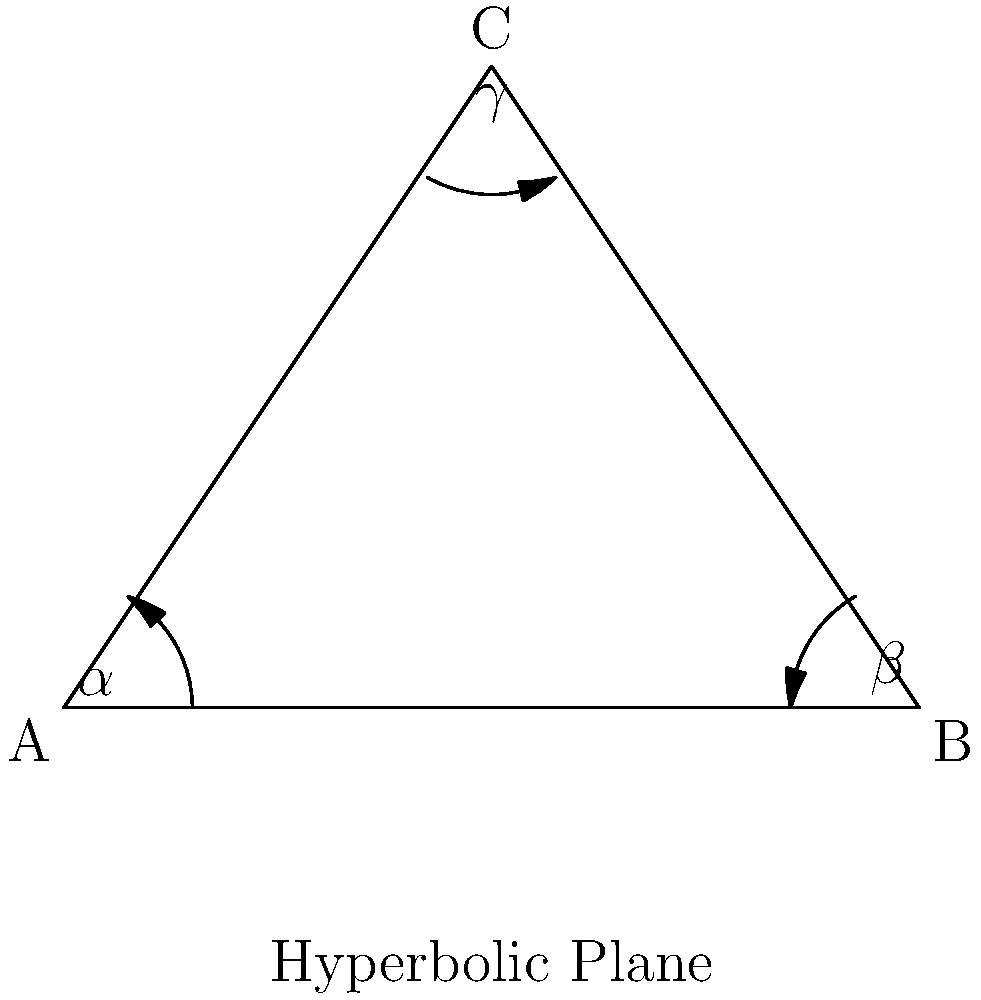Em um plano hiperbólico, um triângulo tem ângulos internos $\alpha$, $\beta$, e $\gamma$. Sabendo que a soma dos ângulos internos de um triângulo em um plano hiperbólico é sempre menor que 180°, e que neste triângulo específico a soma é igual a 150°, qual é o valor da deficiência angular (a diferença entre 180° e a soma dos ângulos internos)? Para resolver esta questão, vamos seguir os seguintes passos:

1) Em um plano euclidiano, a soma dos ângulos internos de um triângulo é sempre 180°. No entanto, em um plano hiperbólico, esta soma é sempre menor que 180°.

2) A deficiência angular é definida como a diferença entre 180° e a soma dos ângulos internos do triângulo no plano hiperbólico.

3) Neste caso, nos é dado que a soma dos ângulos internos é 150°.

4) Portanto, podemos calcular a deficiência angular da seguinte forma:

   Deficiência angular = 180° - (soma dos ângulos internos)
   
   Deficiência angular = 180° - 150°
   
   Deficiência angular = 30°

5) Este resultado nos mostra quanto a geometria deste triângulo no plano hiperbólico se desvia da geometria euclidiana.

Esta informação é particularmente interessante para influenciadores digitais que trabalham com conteúdo educacional ou científico, pois demonstra como conceitos geométricos podem variar dependendo do tipo de espaço em que estamos trabalhando.
Answer: 30° 